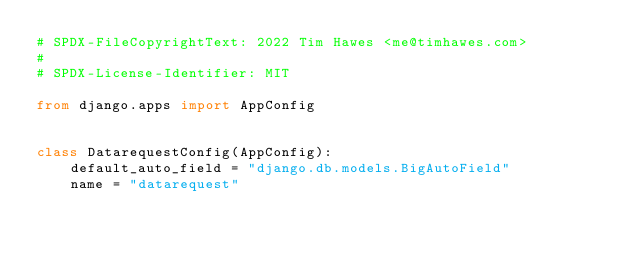<code> <loc_0><loc_0><loc_500><loc_500><_Python_># SPDX-FileCopyrightText: 2022 Tim Hawes <me@timhawes.com>
#
# SPDX-License-Identifier: MIT

from django.apps import AppConfig


class DatarequestConfig(AppConfig):
    default_auto_field = "django.db.models.BigAutoField"
    name = "datarequest"
</code> 